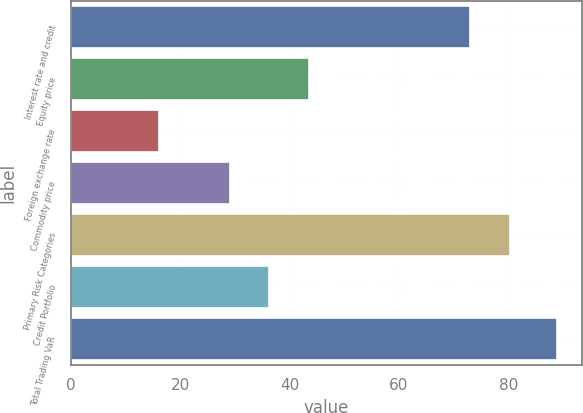<chart> <loc_0><loc_0><loc_500><loc_500><bar_chart><fcel>Interest rate and credit<fcel>Equity price<fcel>Foreign exchange rate<fcel>Commodity price<fcel>Primary Risk Categories<fcel>Credit Portfolio<fcel>Total Trading VaR<nl><fcel>73<fcel>43.6<fcel>16<fcel>29<fcel>80.3<fcel>36.3<fcel>89<nl></chart> 